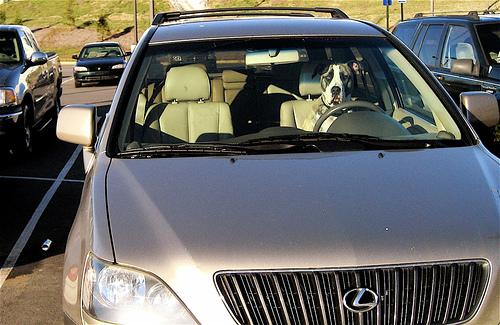Question: how many dogs are in the image?
Choices:
A. Two.
B. One.
C. Five.
D. Six.
Answer with the letter. Answer: B Question: what color is the car with the dog in it?
Choices:
A. Gray.
B. Tan.
C. Blue.
D. Yellow.
Answer with the letter. Answer: B Question: what brand of car is the dog sitting in?
Choices:
A. Mercedes.
B. Lamborghini.
C. Toyota.
D. Lexus.
Answer with the letter. Answer: D Question: what type interior does the car with the dog have?
Choices:
A. Leather.
B. Canvas.
C. Microfiber.
D. Cotton.
Answer with the letter. Answer: A Question: what is the color of the grass in the background?
Choices:
A. Blue.
B. Green.
C. Red.
D. Yellow.
Answer with the letter. Answer: B Question: what are the colors of the dog?
Choices:
A. Black and white.
B. Brown and white.
C. Black and brown.
D. Yellow and white.
Answer with the letter. Answer: B 